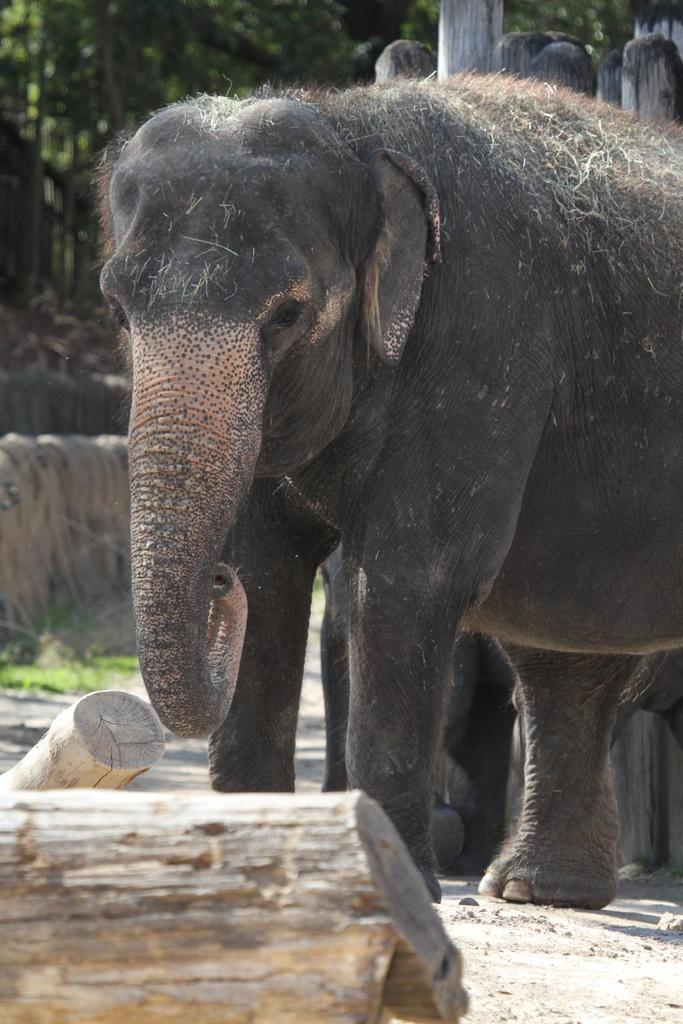What animal can be seen in the picture? There is an elephant in the picture. What part of the trees can be seen in the picture? The trunks of trees are visible in the picture. What type of terrain is visible in the picture? The ground is visible in the picture. What type of vegetation is present in the picture? There is grass in the picture. What structures are present in the picture? Poles are present in the picture. What else can be seen in the picture besides the elephant? Trees are visible in the picture. What type of salt can be seen on the elephant's back in the picture? There is no salt present in the picture; it features an elephant, trees, and other elements as described in the conversation. --- Facts: 1. There is a car in the picture. 2. The car is red. 3. The car has four wheels. 4. There is a road in the picture. 5. The road is paved. 6. There are buildings in the background of the picture. Absurd Topics: birds, ocean, umbrella Conversation: What vehicle is in the picture? There is a car in the picture. What color is the car? The car is red. How many wheels does the car have? The car has four wheels. What type of surface is visible in the picture? There is a road in the picture, and it is paved. What can be seen in the background of the picture? There are buildings in the background of the picture. Reasoning: Let's think step by step in order to produce the conversation. We start by identifying the main subject in the image, which is the car. Then, we expand the conversation to include other details about the car, such as its color and the number of wheels. Next, we describe the road and its condition, followed by the background elements, which are the buildings. Each question is designed to elicit a specific detail about the image that is known from the provided facts. Absurd Question/Answer: Can you see any birds flying over the ocean in the picture? There is no ocean or birds present in the picture; it features a red car, a paved road, and buildings in the background. 